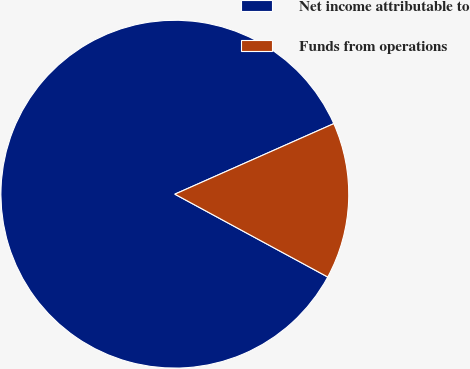Convert chart to OTSL. <chart><loc_0><loc_0><loc_500><loc_500><pie_chart><fcel>Net income attributable to<fcel>Funds from operations<nl><fcel>85.45%<fcel>14.55%<nl></chart> 